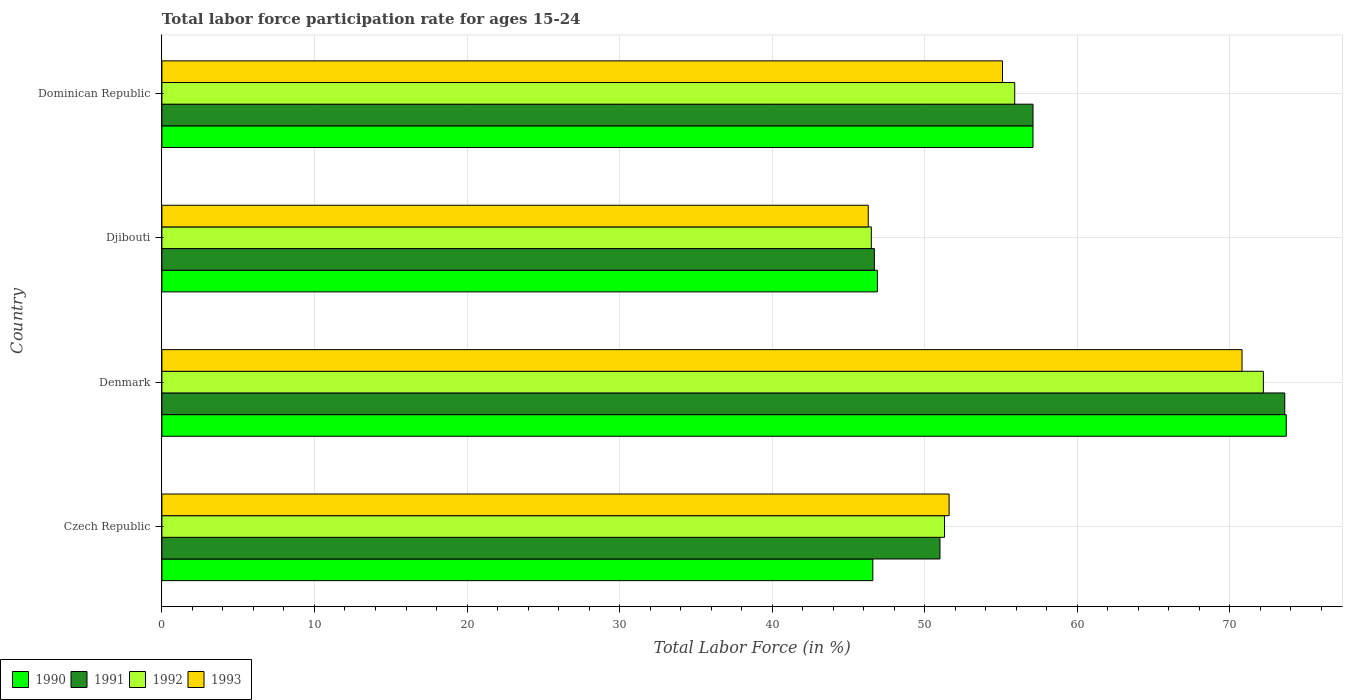How many groups of bars are there?
Offer a very short reply. 4. Are the number of bars on each tick of the Y-axis equal?
Your answer should be very brief. Yes. What is the label of the 4th group of bars from the top?
Ensure brevity in your answer.  Czech Republic. What is the labor force participation rate in 1993 in Djibouti?
Your response must be concise. 46.3. Across all countries, what is the maximum labor force participation rate in 1991?
Your response must be concise. 73.6. Across all countries, what is the minimum labor force participation rate in 1991?
Your answer should be compact. 46.7. In which country was the labor force participation rate in 1990 minimum?
Provide a succinct answer. Czech Republic. What is the total labor force participation rate in 1992 in the graph?
Offer a very short reply. 225.9. What is the difference between the labor force participation rate in 1990 in Czech Republic and that in Djibouti?
Provide a short and direct response. -0.3. What is the average labor force participation rate in 1993 per country?
Offer a terse response. 55.95. What is the difference between the labor force participation rate in 1990 and labor force participation rate in 1991 in Denmark?
Keep it short and to the point. 0.1. What is the ratio of the labor force participation rate in 1993 in Djibouti to that in Dominican Republic?
Your answer should be very brief. 0.84. What is the difference between the highest and the second highest labor force participation rate in 1990?
Provide a short and direct response. 16.6. What is the difference between the highest and the lowest labor force participation rate in 1990?
Your answer should be very brief. 27.1. In how many countries, is the labor force participation rate in 1993 greater than the average labor force participation rate in 1993 taken over all countries?
Ensure brevity in your answer.  1. Is it the case that in every country, the sum of the labor force participation rate in 1993 and labor force participation rate in 1991 is greater than the labor force participation rate in 1992?
Your answer should be compact. Yes. Are all the bars in the graph horizontal?
Make the answer very short. Yes. Are the values on the major ticks of X-axis written in scientific E-notation?
Offer a terse response. No. Does the graph contain any zero values?
Your answer should be very brief. No. Where does the legend appear in the graph?
Offer a terse response. Bottom left. How are the legend labels stacked?
Your answer should be compact. Horizontal. What is the title of the graph?
Make the answer very short. Total labor force participation rate for ages 15-24. Does "1965" appear as one of the legend labels in the graph?
Provide a succinct answer. No. What is the Total Labor Force (in %) of 1990 in Czech Republic?
Make the answer very short. 46.6. What is the Total Labor Force (in %) in 1992 in Czech Republic?
Offer a very short reply. 51.3. What is the Total Labor Force (in %) of 1993 in Czech Republic?
Offer a very short reply. 51.6. What is the Total Labor Force (in %) in 1990 in Denmark?
Give a very brief answer. 73.7. What is the Total Labor Force (in %) in 1991 in Denmark?
Ensure brevity in your answer.  73.6. What is the Total Labor Force (in %) of 1992 in Denmark?
Offer a very short reply. 72.2. What is the Total Labor Force (in %) of 1993 in Denmark?
Offer a very short reply. 70.8. What is the Total Labor Force (in %) of 1990 in Djibouti?
Provide a succinct answer. 46.9. What is the Total Labor Force (in %) of 1991 in Djibouti?
Make the answer very short. 46.7. What is the Total Labor Force (in %) of 1992 in Djibouti?
Your answer should be compact. 46.5. What is the Total Labor Force (in %) of 1993 in Djibouti?
Give a very brief answer. 46.3. What is the Total Labor Force (in %) of 1990 in Dominican Republic?
Provide a short and direct response. 57.1. What is the Total Labor Force (in %) of 1991 in Dominican Republic?
Make the answer very short. 57.1. What is the Total Labor Force (in %) of 1992 in Dominican Republic?
Offer a terse response. 55.9. What is the Total Labor Force (in %) of 1993 in Dominican Republic?
Provide a succinct answer. 55.1. Across all countries, what is the maximum Total Labor Force (in %) in 1990?
Provide a succinct answer. 73.7. Across all countries, what is the maximum Total Labor Force (in %) in 1991?
Provide a succinct answer. 73.6. Across all countries, what is the maximum Total Labor Force (in %) of 1992?
Ensure brevity in your answer.  72.2. Across all countries, what is the maximum Total Labor Force (in %) of 1993?
Your answer should be very brief. 70.8. Across all countries, what is the minimum Total Labor Force (in %) of 1990?
Ensure brevity in your answer.  46.6. Across all countries, what is the minimum Total Labor Force (in %) in 1991?
Ensure brevity in your answer.  46.7. Across all countries, what is the minimum Total Labor Force (in %) of 1992?
Your answer should be very brief. 46.5. Across all countries, what is the minimum Total Labor Force (in %) of 1993?
Offer a very short reply. 46.3. What is the total Total Labor Force (in %) in 1990 in the graph?
Offer a very short reply. 224.3. What is the total Total Labor Force (in %) in 1991 in the graph?
Your answer should be very brief. 228.4. What is the total Total Labor Force (in %) of 1992 in the graph?
Give a very brief answer. 225.9. What is the total Total Labor Force (in %) of 1993 in the graph?
Keep it short and to the point. 223.8. What is the difference between the Total Labor Force (in %) in 1990 in Czech Republic and that in Denmark?
Give a very brief answer. -27.1. What is the difference between the Total Labor Force (in %) in 1991 in Czech Republic and that in Denmark?
Give a very brief answer. -22.6. What is the difference between the Total Labor Force (in %) of 1992 in Czech Republic and that in Denmark?
Give a very brief answer. -20.9. What is the difference between the Total Labor Force (in %) of 1993 in Czech Republic and that in Denmark?
Ensure brevity in your answer.  -19.2. What is the difference between the Total Labor Force (in %) of 1991 in Czech Republic and that in Djibouti?
Provide a succinct answer. 4.3. What is the difference between the Total Labor Force (in %) of 1990 in Czech Republic and that in Dominican Republic?
Keep it short and to the point. -10.5. What is the difference between the Total Labor Force (in %) of 1990 in Denmark and that in Djibouti?
Your response must be concise. 26.8. What is the difference between the Total Labor Force (in %) of 1991 in Denmark and that in Djibouti?
Offer a terse response. 26.9. What is the difference between the Total Labor Force (in %) in 1992 in Denmark and that in Djibouti?
Provide a short and direct response. 25.7. What is the difference between the Total Labor Force (in %) of 1992 in Denmark and that in Dominican Republic?
Offer a very short reply. 16.3. What is the difference between the Total Labor Force (in %) in 1993 in Denmark and that in Dominican Republic?
Provide a succinct answer. 15.7. What is the difference between the Total Labor Force (in %) in 1990 in Djibouti and that in Dominican Republic?
Your answer should be very brief. -10.2. What is the difference between the Total Labor Force (in %) in 1991 in Djibouti and that in Dominican Republic?
Your answer should be very brief. -10.4. What is the difference between the Total Labor Force (in %) in 1990 in Czech Republic and the Total Labor Force (in %) in 1991 in Denmark?
Offer a very short reply. -27. What is the difference between the Total Labor Force (in %) of 1990 in Czech Republic and the Total Labor Force (in %) of 1992 in Denmark?
Provide a succinct answer. -25.6. What is the difference between the Total Labor Force (in %) in 1990 in Czech Republic and the Total Labor Force (in %) in 1993 in Denmark?
Keep it short and to the point. -24.2. What is the difference between the Total Labor Force (in %) in 1991 in Czech Republic and the Total Labor Force (in %) in 1992 in Denmark?
Your answer should be compact. -21.2. What is the difference between the Total Labor Force (in %) in 1991 in Czech Republic and the Total Labor Force (in %) in 1993 in Denmark?
Keep it short and to the point. -19.8. What is the difference between the Total Labor Force (in %) in 1992 in Czech Republic and the Total Labor Force (in %) in 1993 in Denmark?
Ensure brevity in your answer.  -19.5. What is the difference between the Total Labor Force (in %) in 1990 in Czech Republic and the Total Labor Force (in %) in 1993 in Djibouti?
Your answer should be very brief. 0.3. What is the difference between the Total Labor Force (in %) of 1991 in Czech Republic and the Total Labor Force (in %) of 1992 in Djibouti?
Offer a terse response. 4.5. What is the difference between the Total Labor Force (in %) in 1991 in Czech Republic and the Total Labor Force (in %) in 1993 in Djibouti?
Offer a very short reply. 4.7. What is the difference between the Total Labor Force (in %) of 1990 in Czech Republic and the Total Labor Force (in %) of 1991 in Dominican Republic?
Offer a very short reply. -10.5. What is the difference between the Total Labor Force (in %) of 1990 in Czech Republic and the Total Labor Force (in %) of 1992 in Dominican Republic?
Your answer should be compact. -9.3. What is the difference between the Total Labor Force (in %) in 1990 in Czech Republic and the Total Labor Force (in %) in 1993 in Dominican Republic?
Give a very brief answer. -8.5. What is the difference between the Total Labor Force (in %) in 1991 in Czech Republic and the Total Labor Force (in %) in 1992 in Dominican Republic?
Your answer should be compact. -4.9. What is the difference between the Total Labor Force (in %) of 1991 in Czech Republic and the Total Labor Force (in %) of 1993 in Dominican Republic?
Give a very brief answer. -4.1. What is the difference between the Total Labor Force (in %) in 1992 in Czech Republic and the Total Labor Force (in %) in 1993 in Dominican Republic?
Your response must be concise. -3.8. What is the difference between the Total Labor Force (in %) in 1990 in Denmark and the Total Labor Force (in %) in 1992 in Djibouti?
Keep it short and to the point. 27.2. What is the difference between the Total Labor Force (in %) of 1990 in Denmark and the Total Labor Force (in %) of 1993 in Djibouti?
Provide a succinct answer. 27.4. What is the difference between the Total Labor Force (in %) in 1991 in Denmark and the Total Labor Force (in %) in 1992 in Djibouti?
Your answer should be very brief. 27.1. What is the difference between the Total Labor Force (in %) in 1991 in Denmark and the Total Labor Force (in %) in 1993 in Djibouti?
Ensure brevity in your answer.  27.3. What is the difference between the Total Labor Force (in %) in 1992 in Denmark and the Total Labor Force (in %) in 1993 in Djibouti?
Keep it short and to the point. 25.9. What is the difference between the Total Labor Force (in %) of 1990 in Denmark and the Total Labor Force (in %) of 1991 in Dominican Republic?
Provide a short and direct response. 16.6. What is the difference between the Total Labor Force (in %) in 1990 in Denmark and the Total Labor Force (in %) in 1993 in Dominican Republic?
Ensure brevity in your answer.  18.6. What is the difference between the Total Labor Force (in %) in 1990 in Djibouti and the Total Labor Force (in %) in 1993 in Dominican Republic?
Your answer should be compact. -8.2. What is the average Total Labor Force (in %) in 1990 per country?
Give a very brief answer. 56.08. What is the average Total Labor Force (in %) of 1991 per country?
Your answer should be very brief. 57.1. What is the average Total Labor Force (in %) of 1992 per country?
Offer a very short reply. 56.48. What is the average Total Labor Force (in %) in 1993 per country?
Provide a succinct answer. 55.95. What is the difference between the Total Labor Force (in %) in 1990 and Total Labor Force (in %) in 1993 in Czech Republic?
Your response must be concise. -5. What is the difference between the Total Labor Force (in %) of 1991 and Total Labor Force (in %) of 1992 in Czech Republic?
Offer a very short reply. -0.3. What is the difference between the Total Labor Force (in %) in 1990 and Total Labor Force (in %) in 1991 in Denmark?
Provide a short and direct response. 0.1. What is the difference between the Total Labor Force (in %) of 1992 and Total Labor Force (in %) of 1993 in Denmark?
Your answer should be compact. 1.4. What is the difference between the Total Labor Force (in %) of 1990 and Total Labor Force (in %) of 1991 in Djibouti?
Provide a succinct answer. 0.2. What is the difference between the Total Labor Force (in %) in 1990 and Total Labor Force (in %) in 1993 in Djibouti?
Keep it short and to the point. 0.6. What is the difference between the Total Labor Force (in %) of 1991 and Total Labor Force (in %) of 1992 in Djibouti?
Offer a terse response. 0.2. What is the difference between the Total Labor Force (in %) in 1990 and Total Labor Force (in %) in 1992 in Dominican Republic?
Ensure brevity in your answer.  1.2. What is the difference between the Total Labor Force (in %) of 1991 and Total Labor Force (in %) of 1993 in Dominican Republic?
Offer a terse response. 2. What is the difference between the Total Labor Force (in %) of 1992 and Total Labor Force (in %) of 1993 in Dominican Republic?
Give a very brief answer. 0.8. What is the ratio of the Total Labor Force (in %) in 1990 in Czech Republic to that in Denmark?
Offer a terse response. 0.63. What is the ratio of the Total Labor Force (in %) in 1991 in Czech Republic to that in Denmark?
Offer a terse response. 0.69. What is the ratio of the Total Labor Force (in %) in 1992 in Czech Republic to that in Denmark?
Keep it short and to the point. 0.71. What is the ratio of the Total Labor Force (in %) of 1993 in Czech Republic to that in Denmark?
Offer a very short reply. 0.73. What is the ratio of the Total Labor Force (in %) of 1990 in Czech Republic to that in Djibouti?
Ensure brevity in your answer.  0.99. What is the ratio of the Total Labor Force (in %) in 1991 in Czech Republic to that in Djibouti?
Offer a very short reply. 1.09. What is the ratio of the Total Labor Force (in %) in 1992 in Czech Republic to that in Djibouti?
Make the answer very short. 1.1. What is the ratio of the Total Labor Force (in %) in 1993 in Czech Republic to that in Djibouti?
Offer a terse response. 1.11. What is the ratio of the Total Labor Force (in %) of 1990 in Czech Republic to that in Dominican Republic?
Offer a very short reply. 0.82. What is the ratio of the Total Labor Force (in %) of 1991 in Czech Republic to that in Dominican Republic?
Offer a very short reply. 0.89. What is the ratio of the Total Labor Force (in %) of 1992 in Czech Republic to that in Dominican Republic?
Keep it short and to the point. 0.92. What is the ratio of the Total Labor Force (in %) of 1993 in Czech Republic to that in Dominican Republic?
Your answer should be very brief. 0.94. What is the ratio of the Total Labor Force (in %) of 1990 in Denmark to that in Djibouti?
Offer a very short reply. 1.57. What is the ratio of the Total Labor Force (in %) in 1991 in Denmark to that in Djibouti?
Provide a succinct answer. 1.58. What is the ratio of the Total Labor Force (in %) of 1992 in Denmark to that in Djibouti?
Make the answer very short. 1.55. What is the ratio of the Total Labor Force (in %) of 1993 in Denmark to that in Djibouti?
Make the answer very short. 1.53. What is the ratio of the Total Labor Force (in %) of 1990 in Denmark to that in Dominican Republic?
Ensure brevity in your answer.  1.29. What is the ratio of the Total Labor Force (in %) in 1991 in Denmark to that in Dominican Republic?
Ensure brevity in your answer.  1.29. What is the ratio of the Total Labor Force (in %) in 1992 in Denmark to that in Dominican Republic?
Your response must be concise. 1.29. What is the ratio of the Total Labor Force (in %) of 1993 in Denmark to that in Dominican Republic?
Ensure brevity in your answer.  1.28. What is the ratio of the Total Labor Force (in %) of 1990 in Djibouti to that in Dominican Republic?
Give a very brief answer. 0.82. What is the ratio of the Total Labor Force (in %) in 1991 in Djibouti to that in Dominican Republic?
Provide a short and direct response. 0.82. What is the ratio of the Total Labor Force (in %) of 1992 in Djibouti to that in Dominican Republic?
Provide a short and direct response. 0.83. What is the ratio of the Total Labor Force (in %) in 1993 in Djibouti to that in Dominican Republic?
Your answer should be compact. 0.84. What is the difference between the highest and the lowest Total Labor Force (in %) in 1990?
Give a very brief answer. 27.1. What is the difference between the highest and the lowest Total Labor Force (in %) of 1991?
Your answer should be very brief. 26.9. What is the difference between the highest and the lowest Total Labor Force (in %) of 1992?
Give a very brief answer. 25.7. 